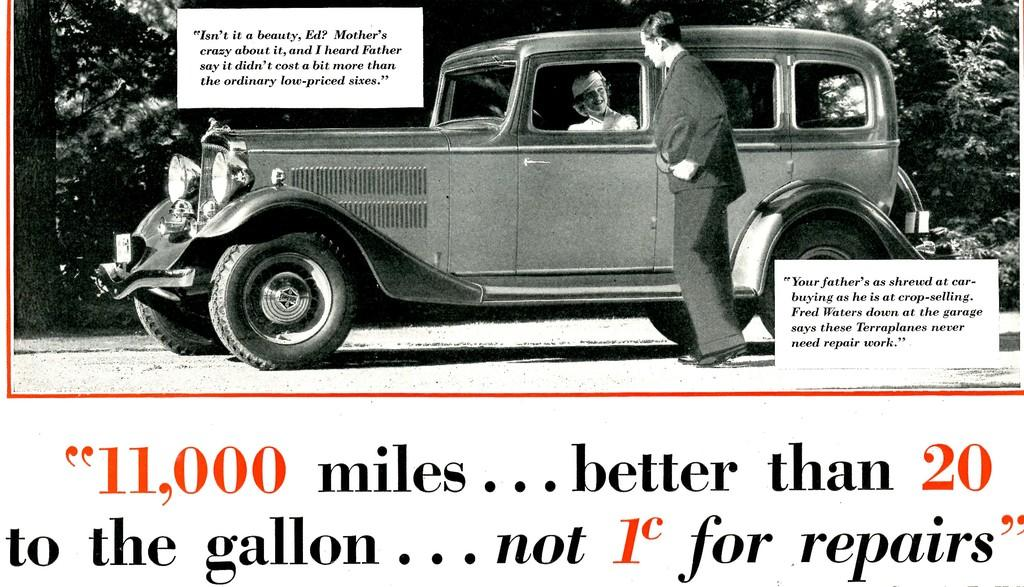What is the color scheme of the image? The image is black and white. Can you describe the main subject in the image? There is a person in the image. What is the person doing in the image? There is a person in a car in the image. What can be seen in the background of the image? There is a road and trees in the image. Where is the text located in the image? The text is located at the bottom of the image. Can you see the person's mother in the image? There is no mention of a mother in the image. --- Facts: 1. There is a person in the image. 2. The person is wearing a hat. 3. The hat is red. 4. The person is holding a book. 5. The book is titled "The Adventures of Tom Sawyer" by Mark Twain. 6. The person is sitting on a bench. 7. The bench is located in a park. Absurd Topics: elephant, piano, cake Conversation: Who or what is the main subject in the image? The main subject in the image is a person. What is the person wearing in the image? The person is wearing a hat. What color is the hat in the image? The hat is red. What is the person holding in the image? The person is holding a book. What is the title of the book the person is holding in the image? The title of the book is "The Adventures of Tom Sawyer" by Mark Twain. What is the person doing in the image? The person is sitting on a bench. Where is the person sitting in the image? The person is sitting on a bench located in a park. Reasoning: Let's think step by step in order to produce the conversation. We start by identifying the main subject of the image, which is a person. Then, we describe the person's attire, specifically mentioning the red hat they are wearing. Next, we observe the person's activity, which is holding a book. We then provide the title of the book, which is "The Adventures of Tom Sawyer" by Mark Twain. After that, we describe the person's posture, which is sitting on a bench. Finally, we mention the location of the bench, which is in a park. Absurd Question/Answer: Can you see an elephant playing a piano in the image? There is no mention of an elephant, a piano, or a cake in the image. The image only features a person, a red hat, a book titled "The Adventures of Tom Sawyer" by Mark Twain, and a bench located in a park. 